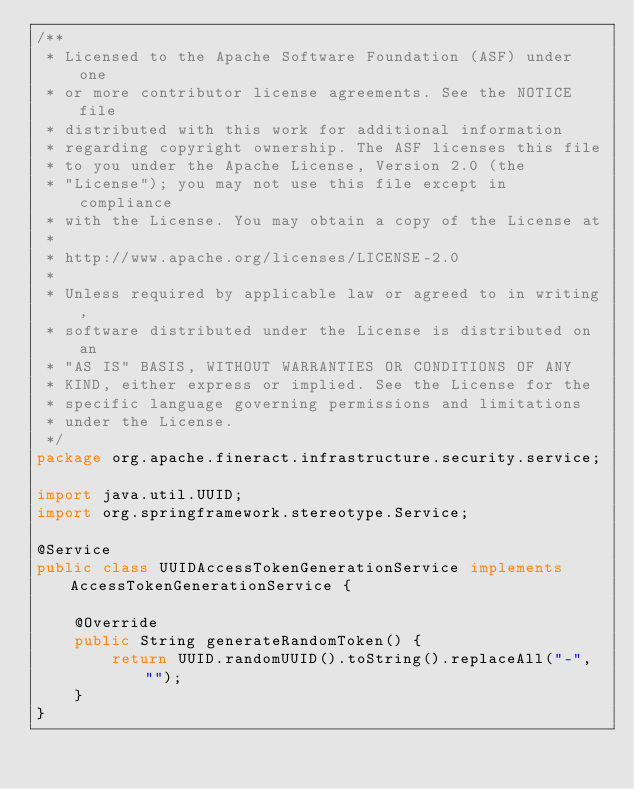<code> <loc_0><loc_0><loc_500><loc_500><_Java_>/**
 * Licensed to the Apache Software Foundation (ASF) under one
 * or more contributor license agreements. See the NOTICE file
 * distributed with this work for additional information
 * regarding copyright ownership. The ASF licenses this file
 * to you under the Apache License, Version 2.0 (the
 * "License"); you may not use this file except in compliance
 * with the License. You may obtain a copy of the License at
 *
 * http://www.apache.org/licenses/LICENSE-2.0
 *
 * Unless required by applicable law or agreed to in writing,
 * software distributed under the License is distributed on an
 * "AS IS" BASIS, WITHOUT WARRANTIES OR CONDITIONS OF ANY
 * KIND, either express or implied. See the License for the
 * specific language governing permissions and limitations
 * under the License.
 */
package org.apache.fineract.infrastructure.security.service;

import java.util.UUID;
import org.springframework.stereotype.Service;

@Service
public class UUIDAccessTokenGenerationService implements AccessTokenGenerationService {

    @Override
    public String generateRandomToken() {
        return UUID.randomUUID().toString().replaceAll("-", "");
    }
}
</code> 